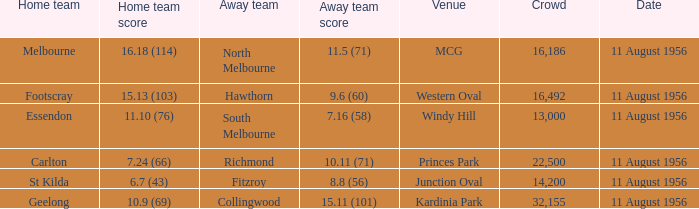What domestic team has a score of 1 Melbourne. 